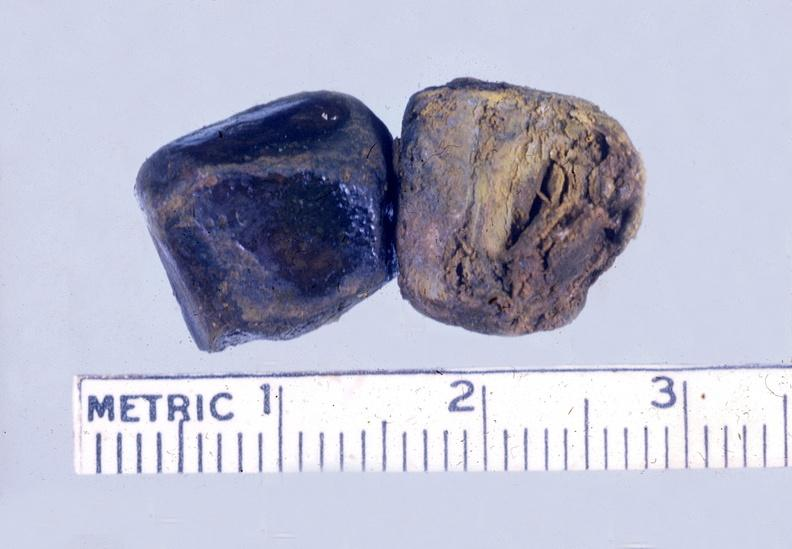what is present?
Answer the question using a single word or phrase. Liver 